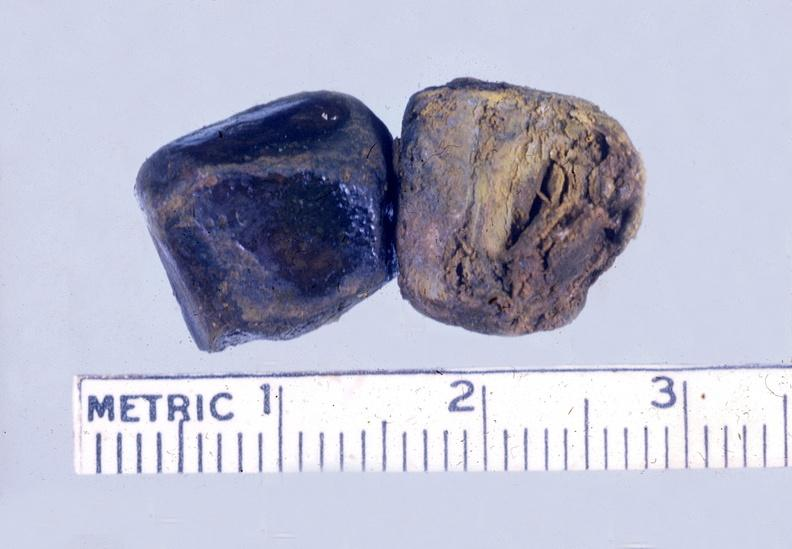what is present?
Answer the question using a single word or phrase. Liver 